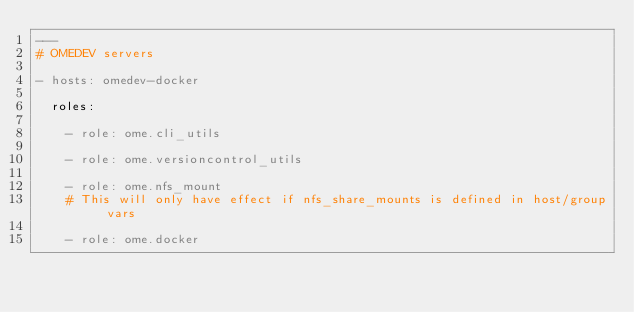<code> <loc_0><loc_0><loc_500><loc_500><_YAML_>---
# OMEDEV servers

- hosts: omedev-docker

  roles:

    - role: ome.cli_utils

    - role: ome.versioncontrol_utils

    - role: ome.nfs_mount
    # This will only have effect if nfs_share_mounts is defined in host/group vars

    - role: ome.docker
</code> 